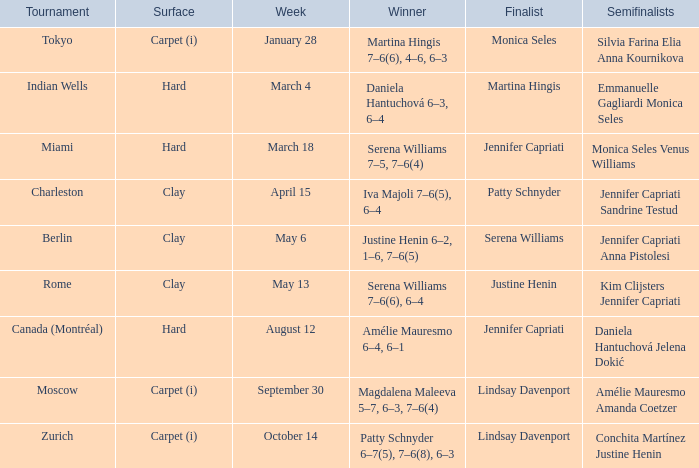Who was the winner in the Indian Wells? Daniela Hantuchová 6–3, 6–4. 